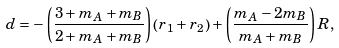<formula> <loc_0><loc_0><loc_500><loc_500>d = - \left ( \frac { 3 + m _ { A } + m _ { B } } { 2 + m _ { A } + m _ { B } } \right ) \left ( r _ { 1 } + r _ { 2 } \right ) + \left ( \frac { m _ { A } - 2 m _ { B } } { m _ { A } + m _ { B } } \right ) R ,</formula> 